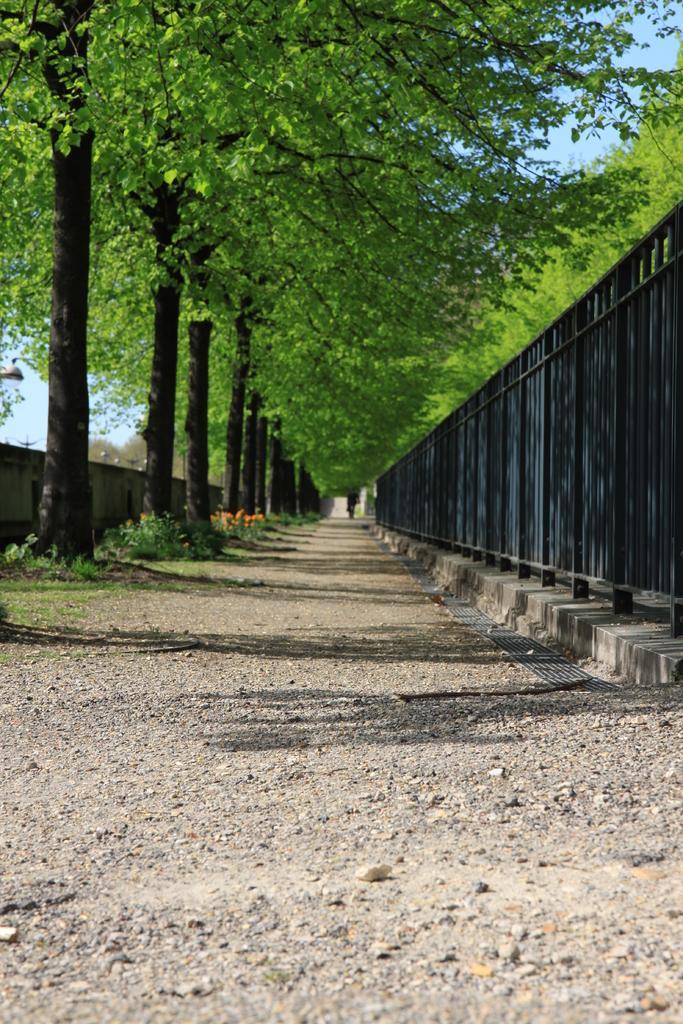In one or two sentences, can you explain what this image depicts? In this image there is a fencing gate at right side of this image and there are some trees as we can see at top of this image and there is a wall at left side of this image. 